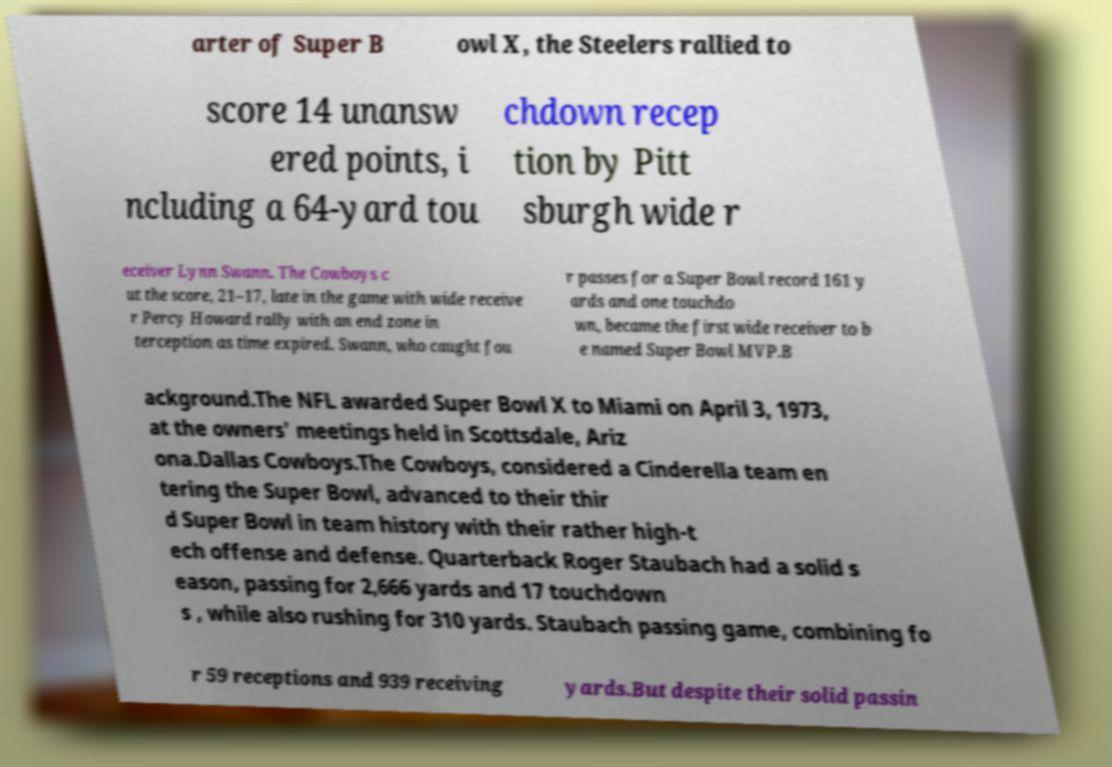I need the written content from this picture converted into text. Can you do that? arter of Super B owl X, the Steelers rallied to score 14 unansw ered points, i ncluding a 64-yard tou chdown recep tion by Pitt sburgh wide r eceiver Lynn Swann. The Cowboys c ut the score, 21–17, late in the game with wide receive r Percy Howard rally with an end zone in terception as time expired. Swann, who caught fou r passes for a Super Bowl record 161 y ards and one touchdo wn, became the first wide receiver to b e named Super Bowl MVP.B ackground.The NFL awarded Super Bowl X to Miami on April 3, 1973, at the owners' meetings held in Scottsdale, Ariz ona.Dallas Cowboys.The Cowboys, considered a Cinderella team en tering the Super Bowl, advanced to their thir d Super Bowl in team history with their rather high-t ech offense and defense. Quarterback Roger Staubach had a solid s eason, passing for 2,666 yards and 17 touchdown s , while also rushing for 310 yards. Staubach passing game, combining fo r 59 receptions and 939 receiving yards.But despite their solid passin 